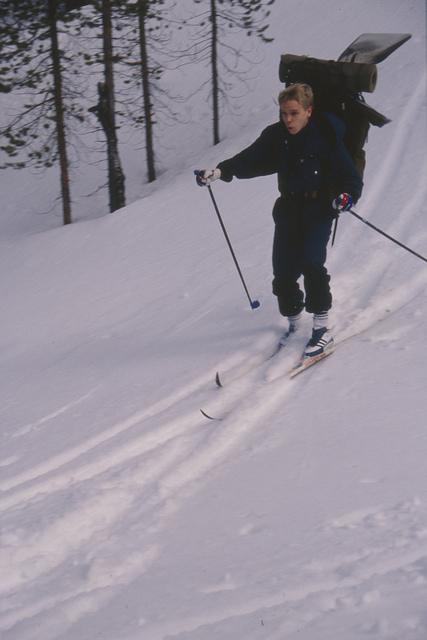What is the shovel carried here meant to be used for first? Please explain your reasoning. snow removal. In case they got stuck or needed to get through a path. 